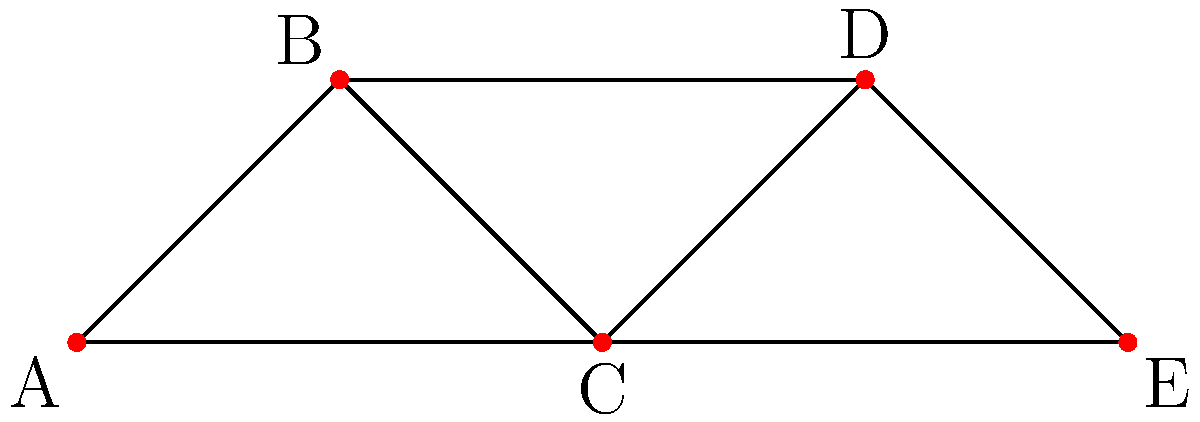In the social network graph of scientific collaborations shown above, vertices represent scientists and edges represent collaborations. What is the betweenness centrality of scientist C? To calculate the betweenness centrality of scientist C, we need to follow these steps:

1) Identify all pairs of scientists that are not directly connected:
   (A,D), (A,E), (B,E)

2) Count the number of shortest paths between these pairs:
   A to D: 2 paths (A-B-D and A-C-D)
   A to E: 1 path (A-C-E)
   B to E: 1 path (B-C-E)

3) Count how many of these shortest paths pass through C:
   A to D: 1 path (A-C-D)
   A to E: 1 path (A-C-E)
   B to E: 1 path (B-C-E)

4) Calculate the fraction of shortest paths that pass through C for each pair:
   A to D: 1/2
   A to E: 1/1 = 1
   B to E: 1/1 = 1

5) Sum these fractions:
   Betweenness centrality of C = 1/2 + 1 + 1 = 5/2 = 2.5

Therefore, the betweenness centrality of scientist C is 2.5.
Answer: 2.5 